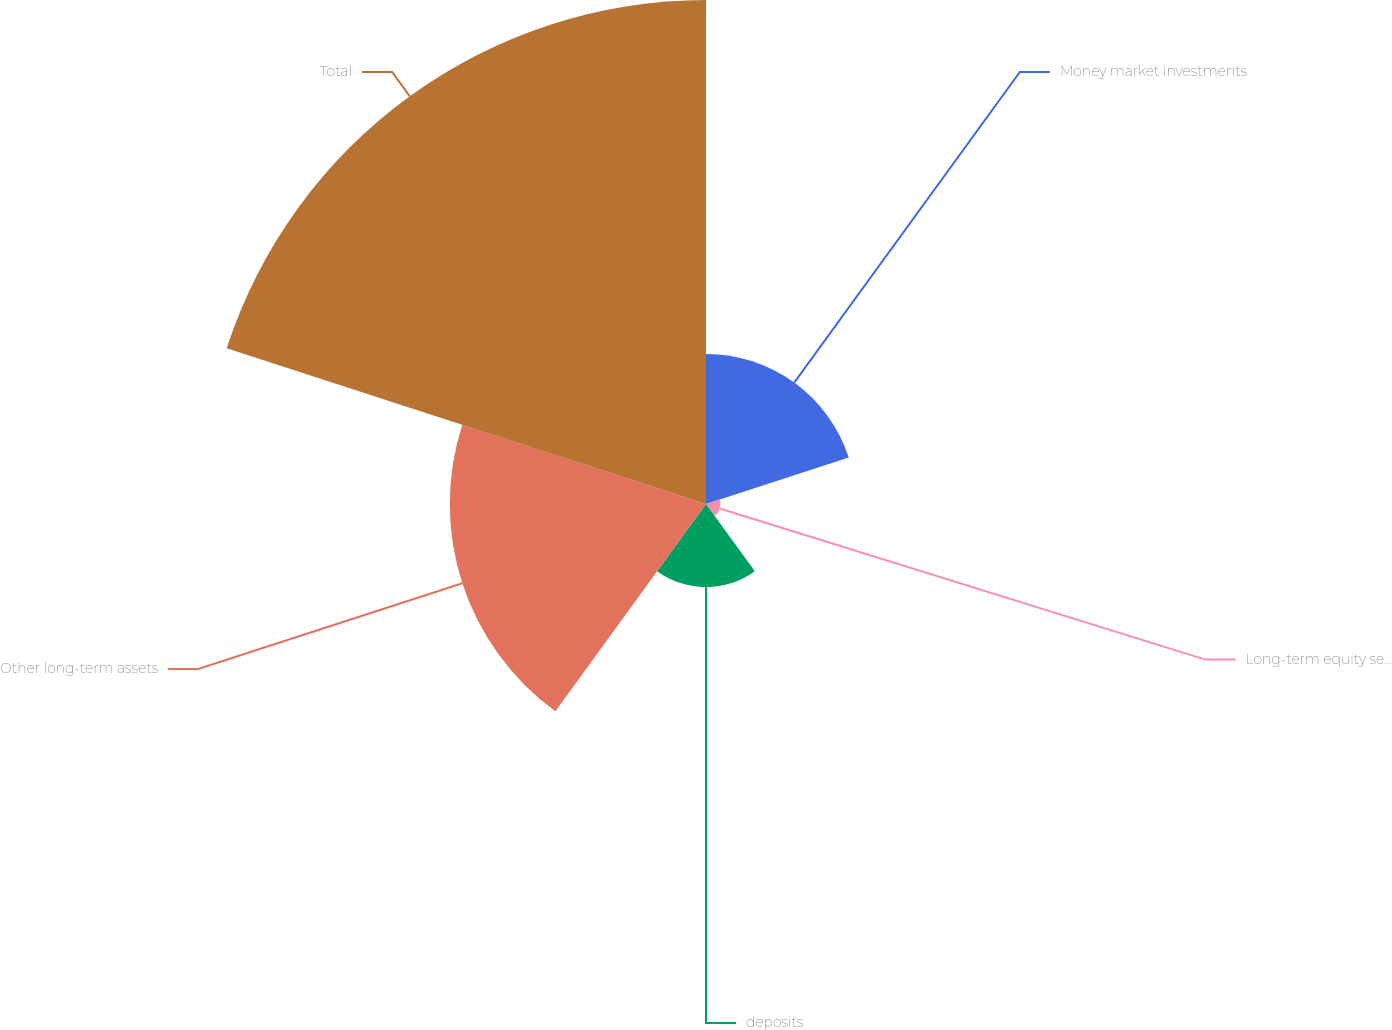<chart> <loc_0><loc_0><loc_500><loc_500><pie_chart><fcel>Money market investments<fcel>Long-term equity securities<fcel>deposits<fcel>Other long-term assets<fcel>Total<nl><fcel>14.89%<fcel>1.44%<fcel>8.25%<fcel>25.42%<fcel>50.0%<nl></chart> 